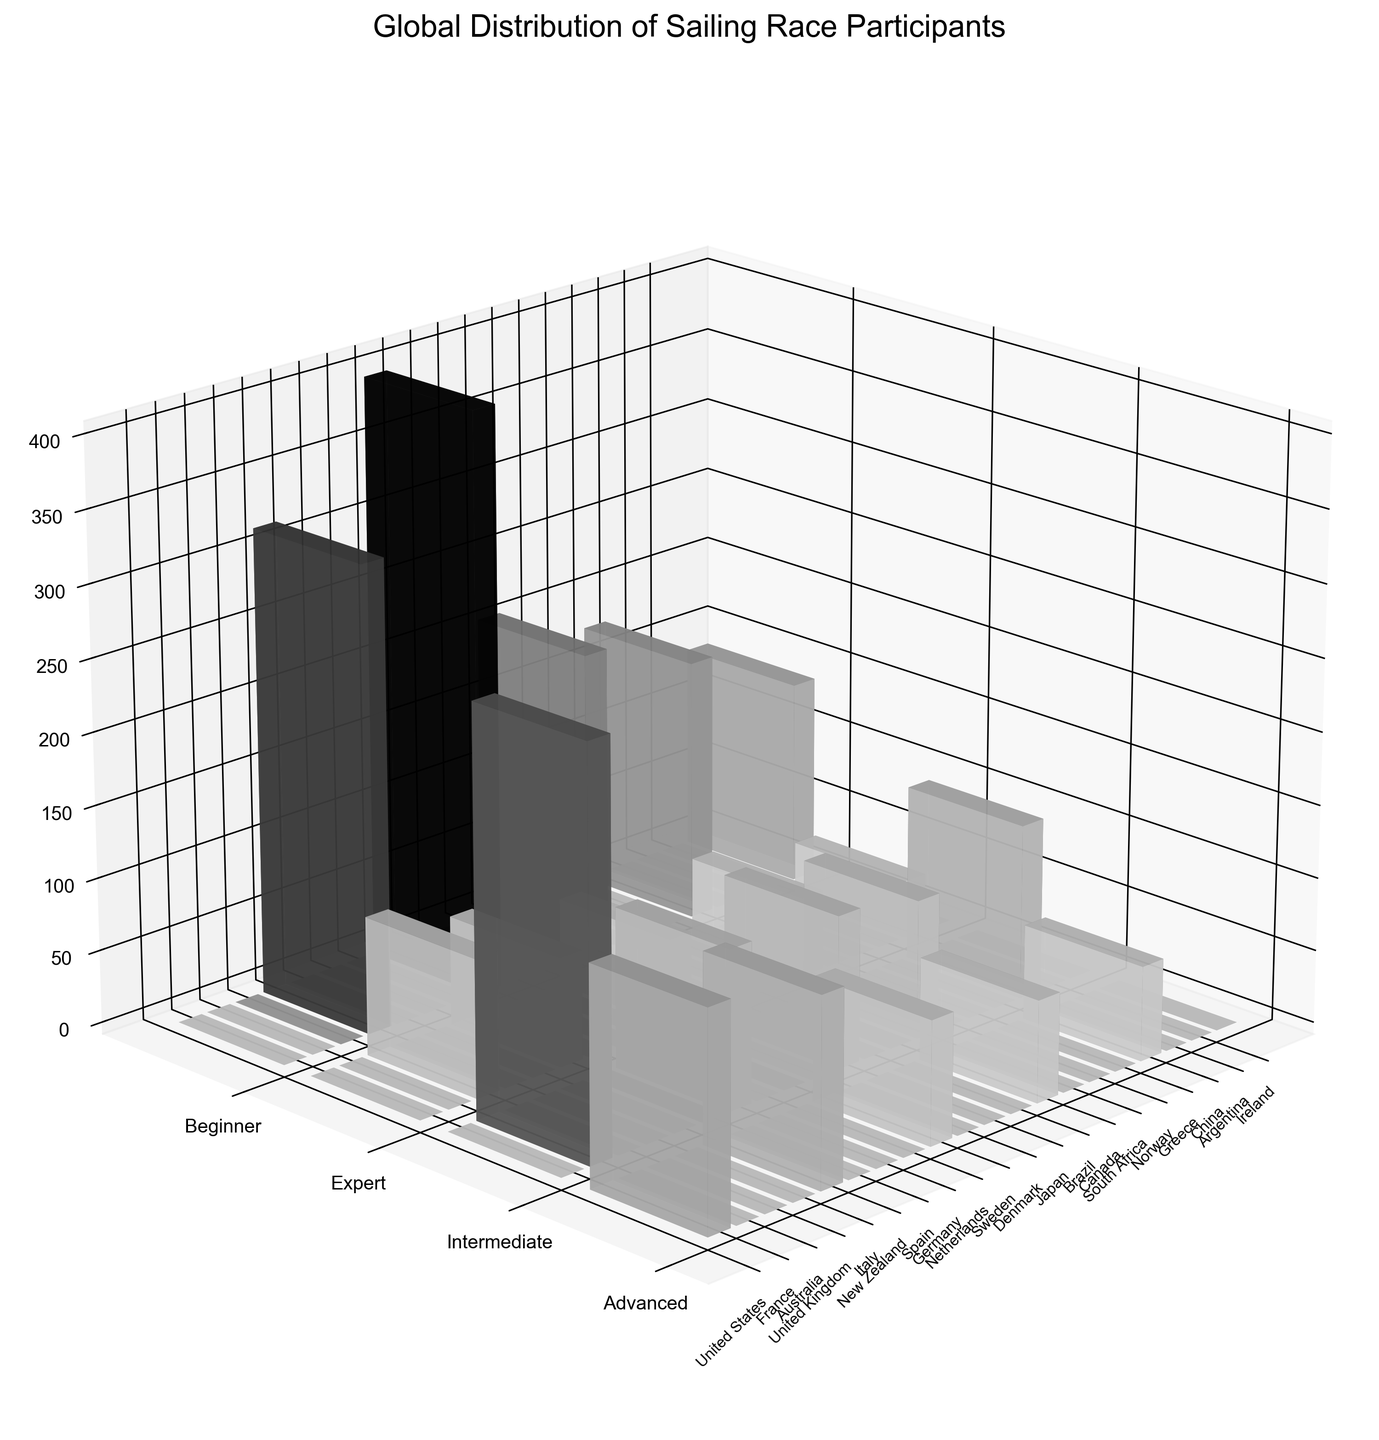which country has the highest number of beginner participants? Look for the tallest bar in the 'Beginner' category on the y-axis. The tallest bar is from Germany.
Answer: Germany how many more beginner participants does Germany have compared to Japan? Germany has 400 beginner participants; Japan has 210. The difference is 400 - 210.
Answer: 190 which skill level has the least number of participants in New Zealand? Check the bars for New Zealand on the skill level axis and find the one with the shortest height. The shortest bar is in the Advanced category.
Answer: Advanced what is the sum of intermediate participants in Denmark and China? Denmark has 105 intermediate participants; China has 120. The sum is 105 + 120.
Answer: 225 how does the number of expert participants in Sweden compare to Argentina? Check the heights of the bars for Expert participants of Sweden and Argentina. Sweden has 60 participants, and Argentina has 40. Sweden has more participants.
Answer: Sweden has more what is the total number of participants in the Maxi Yacht boat class? Look for the number of participants in the rows corresponding to the Maxi Yacht boat class and sum them up. The United States has 150 participants.
Answer: 150 what is the average number of participants in the Advanced skill level across all countries? Sum the participants in the Advanced skill level and divide by the number of countries: (150 + 130 + 85 + 70 + 65) / 5.
Answer: 100 which country has participants in all skill levels? Look for the country names that appear in all three skill levels (Beginner, Intermediate, Advanced). The figure shows no country has participants in all skill levels.
Answer: None which boat class is associated with the largest number of participants in a single skill level? Look for the tallest bar in each skill level; the tallest is in the Beginner skill level for Optimist in Germany.
Answer: Optimist what is the difference between the total number of beginner and expert participants in the dataset? Sum all Beginner and Expert participants separately, then find the difference. Beginners: 320 + 400 + 210 + 180 + 140 = 1,250; Experts: 95 + 75 + 60 + 55 + 40 = 325. The difference is 1,250 - 325.
Answer: 925 